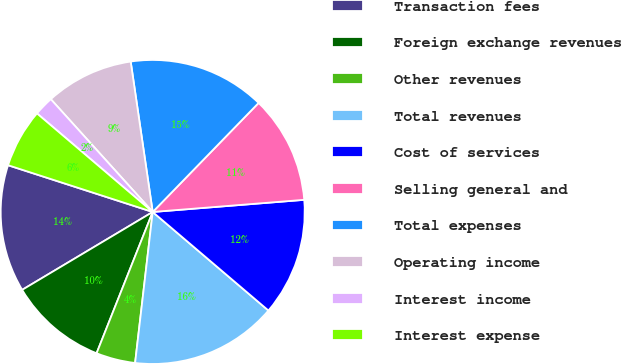<chart> <loc_0><loc_0><loc_500><loc_500><pie_chart><fcel>Transaction fees<fcel>Foreign exchange revenues<fcel>Other revenues<fcel>Total revenues<fcel>Cost of services<fcel>Selling general and<fcel>Total expenses<fcel>Operating income<fcel>Interest income<fcel>Interest expense<nl><fcel>13.54%<fcel>10.42%<fcel>4.17%<fcel>15.62%<fcel>12.5%<fcel>11.46%<fcel>14.58%<fcel>9.38%<fcel>2.08%<fcel>6.25%<nl></chart> 